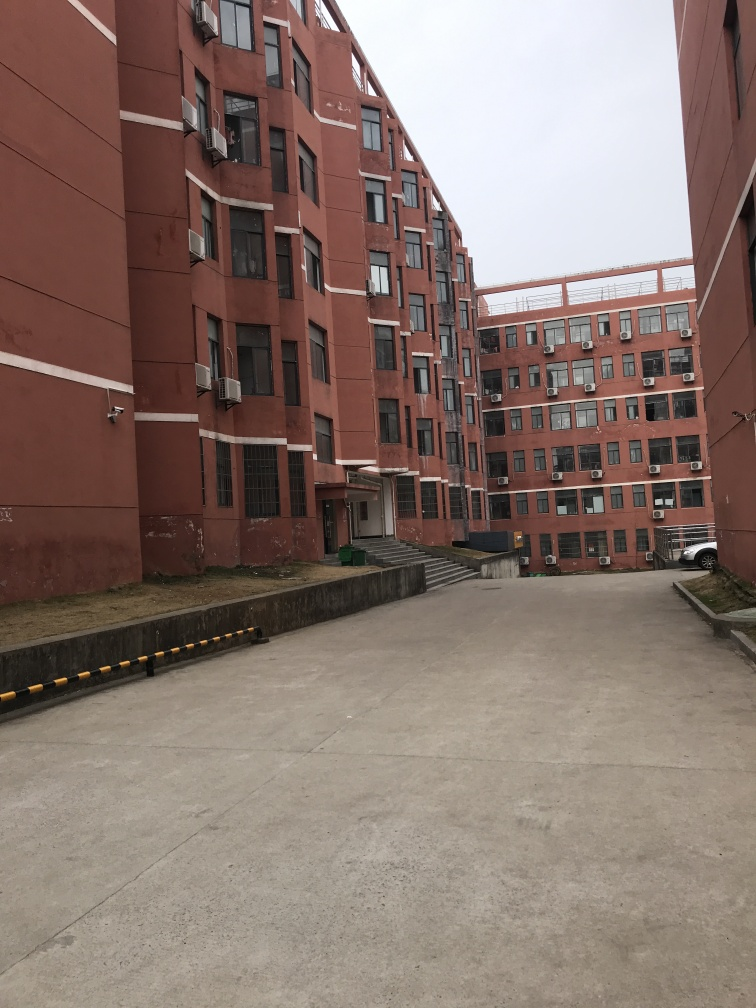Is there anything in this image that suggests the location or cultural context? Specific location indicators are absent; however, the architecture style, including the flat facades, uniform windows, and absence of decorative elements, suggests it could be in a region where practical, cost-effective construction is prioritized. The air conditioning units are common in areas with warmer climates or where buildings use individual rather than centralized climate control systems. What might the presence of the vehicle in the image imply about this location? The vehicle parked in the vicinity hints at the residential nature of this location, indicating that this complex is likely inhabited by people who own or utilize cars. The presence of the vehicle also suggests that this complex is accessible to personal transportation, hinting at a certain level of infrastructure development in the area. 